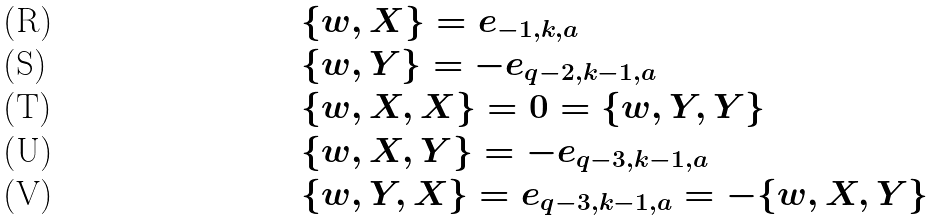<formula> <loc_0><loc_0><loc_500><loc_500>& \{ w , X \} = e _ { - 1 , k , a } \\ & \{ w , Y \} = - e _ { q - 2 , k - 1 , a } \\ & \{ w , X , X \} = 0 = \{ w , Y , Y \} \\ & \{ w , X , Y \} = - e _ { q - 3 , k - 1 , a } \\ & \{ w , Y , X \} = e _ { q - 3 , k - 1 , a } = - \{ w , X , Y \}</formula> 